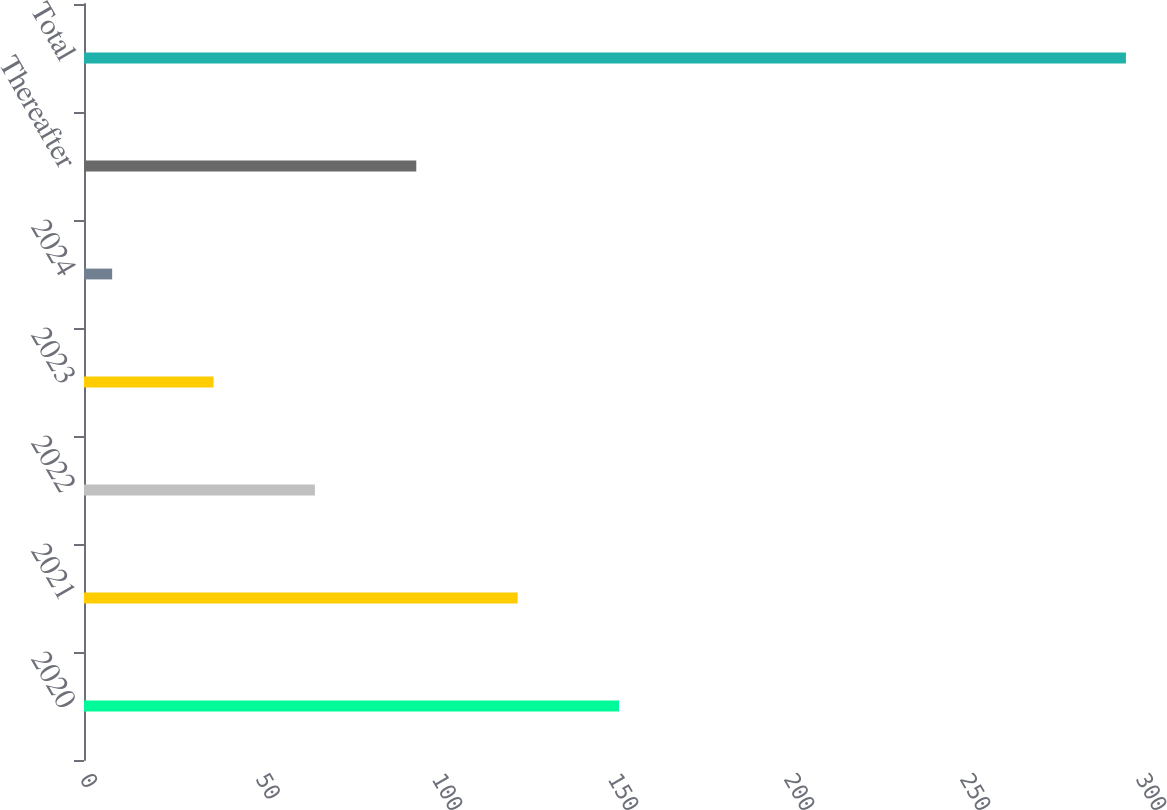Convert chart to OTSL. <chart><loc_0><loc_0><loc_500><loc_500><bar_chart><fcel>2020<fcel>2021<fcel>2022<fcel>2023<fcel>2024<fcel>Thereafter<fcel>Total<nl><fcel>152<fcel>123.2<fcel>65.6<fcel>36.8<fcel>8<fcel>94.4<fcel>296<nl></chart> 